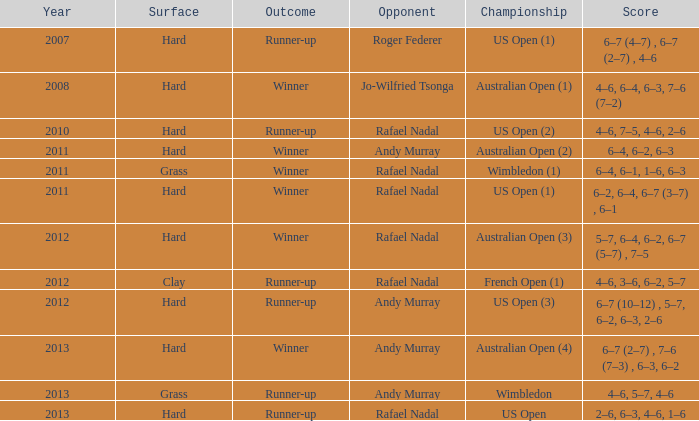What is the outcome of the match with Roger Federer as the opponent? Runner-up. 